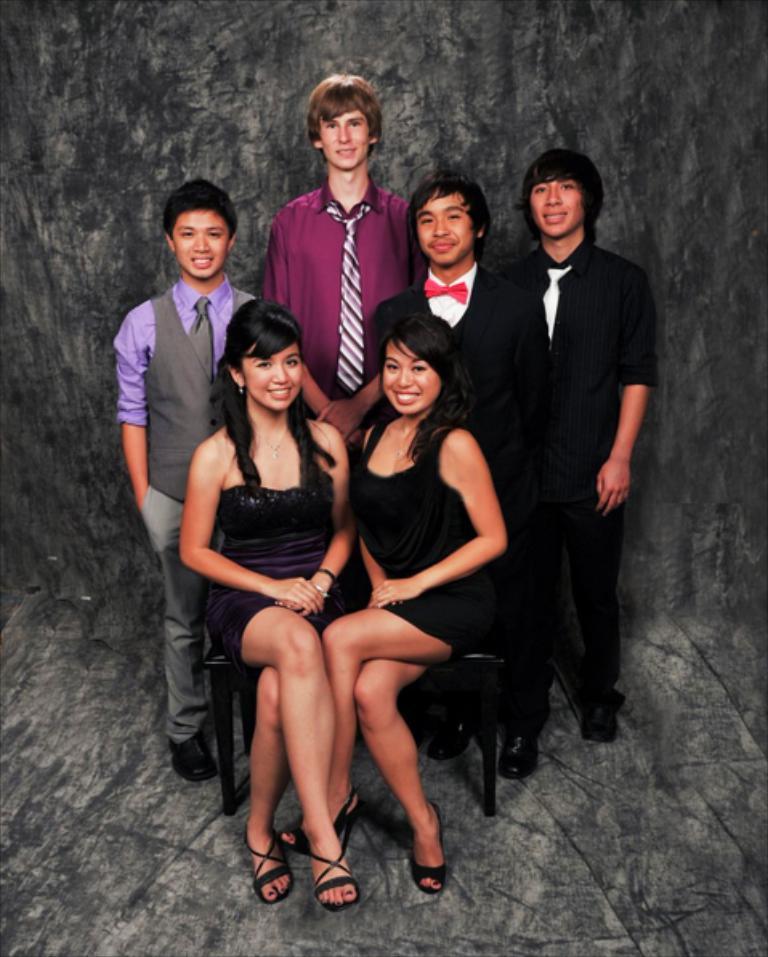In one or two sentences, can you explain what this image depicts? In this image I can see the group of people with different color dresses. I can see two people are sitting on the chair. In the background I can see the grey color wall. 